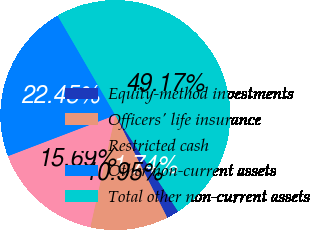Convert chart to OTSL. <chart><loc_0><loc_0><loc_500><loc_500><pie_chart><fcel>Equity-method investments<fcel>Officers' life insurance<fcel>Restricted cash<fcel>Other non-current assets<fcel>Total other non-current assets<nl><fcel>1.74%<fcel>10.95%<fcel>15.69%<fcel>22.45%<fcel>49.17%<nl></chart> 